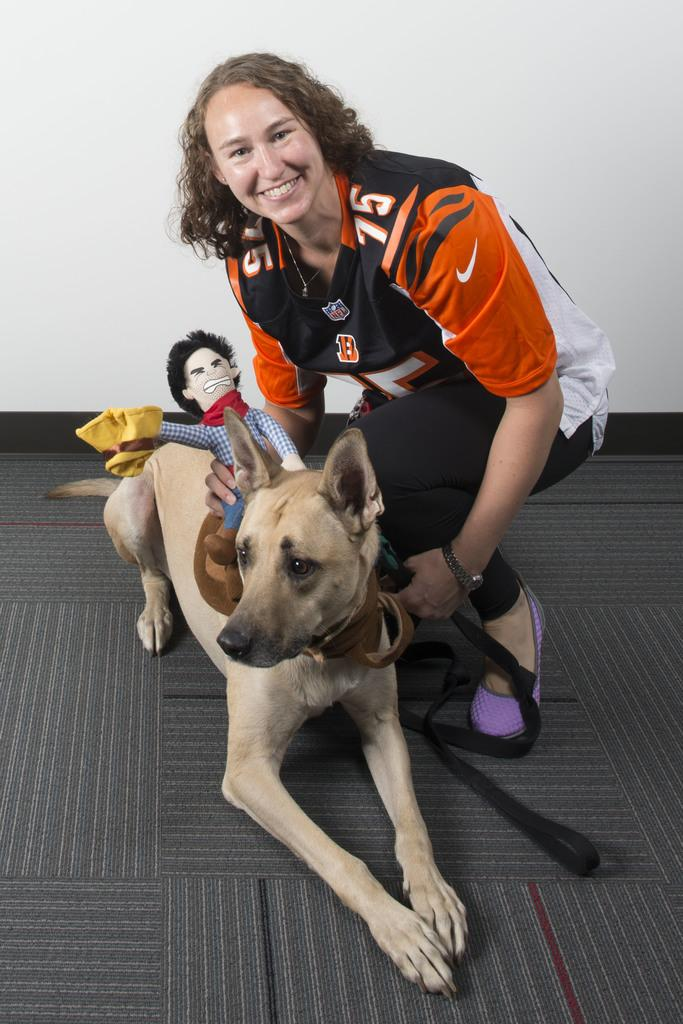Who is present in the image? There is a woman in the image. What is the woman doing in the image? The woman is smiling in the image. What is the woman holding in the image? The woman is holding a soft toy in the image. What is the soft toy placed on? The soft toy is on a dog in the image. What can be seen in the background of the image? There is a wall in the background of the image. What type of sound can be heard coming from the dog in the image? There is no sound coming from the dog in the image, as it is a soft toy and not a real animal. 